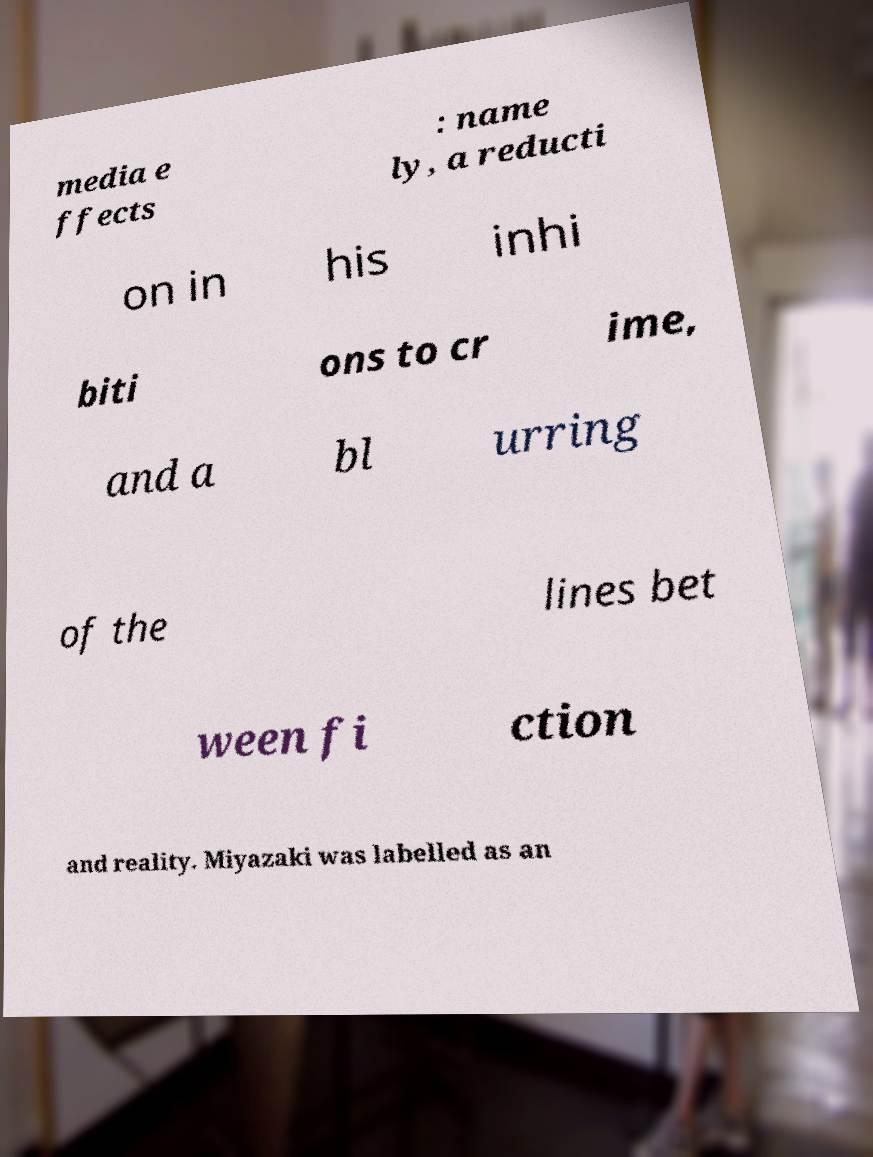I need the written content from this picture converted into text. Can you do that? media e ffects : name ly, a reducti on in his inhi biti ons to cr ime, and a bl urring of the lines bet ween fi ction and reality. Miyazaki was labelled as an 